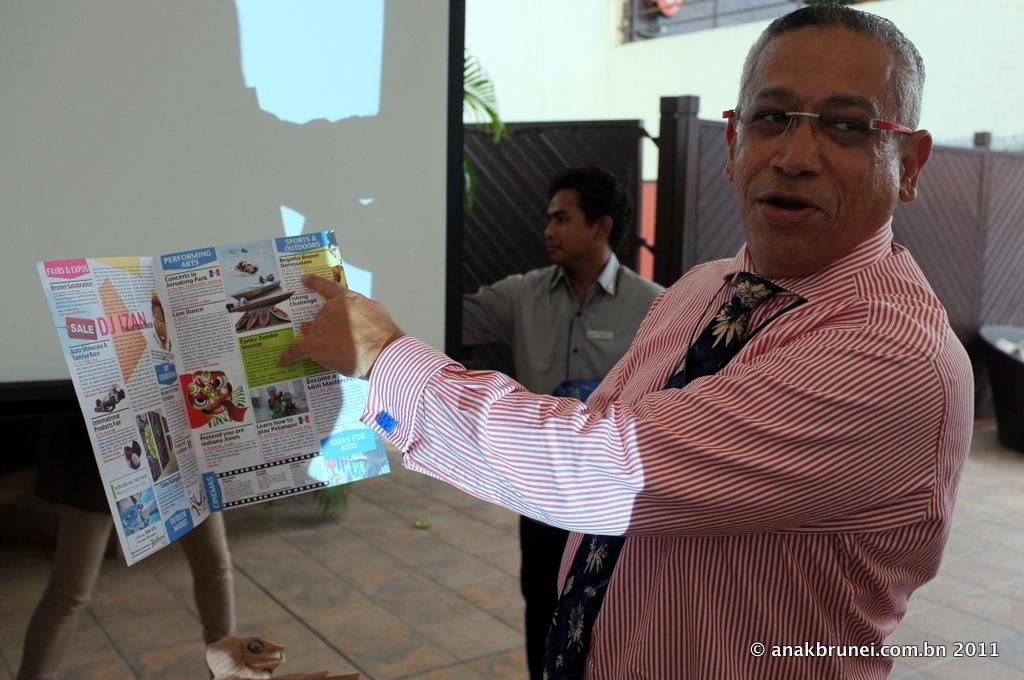What is the man in the middle of the image doing? The man is standing in the middle of the image and holding a paper. Are there any other people in the image? Yes, there are two persons standing behind the man. What can be seen on the screen in the image? The facts do not specify what is visible on the screen. What is located in the background of the image? There is a gate and a plant in the background of the image. Can you hear the bee buzzing in the image? There is no bee present in the image, so it cannot be heard. 